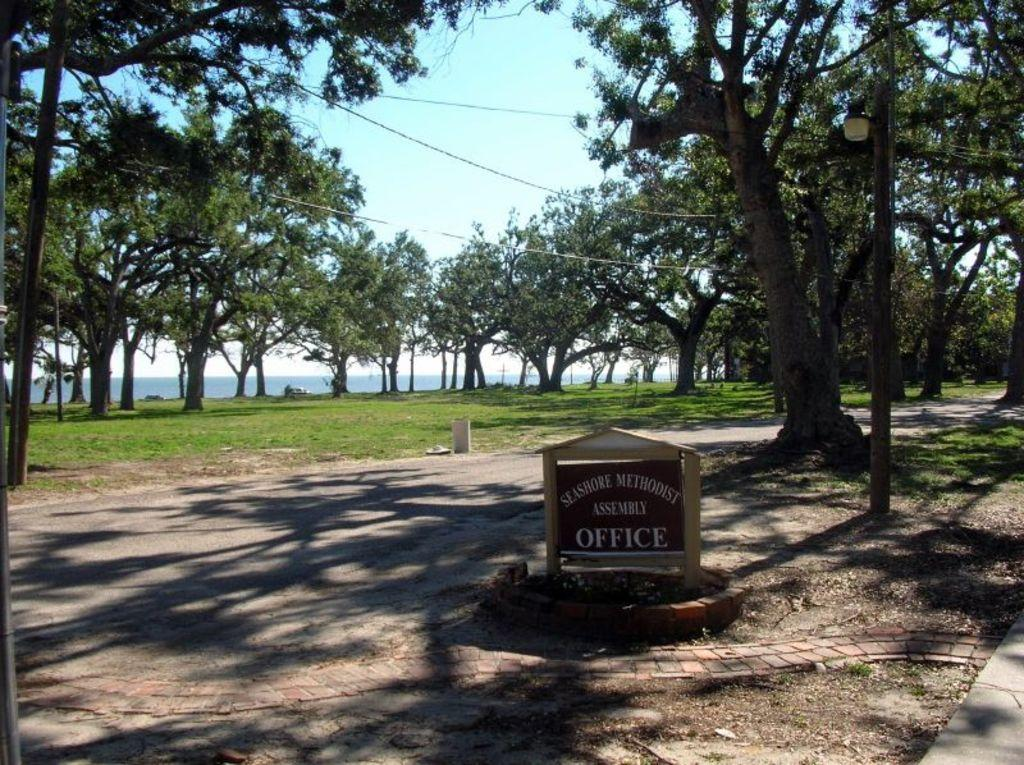What is the main object in the image? There is a sign board in the image. What information does the sign board provide? The sign board has the name of an office. What can be seen behind the sign board? There are trees and grass behind the sign board. What type of surface is visible in the image? There is a water surface visible in the image. What type of juice is being served in the image? There is no juice being served in the image; it features a sign board with the name of an office and a natural setting with trees, grass, and a water surface. Can you see a chain attached to the sign board in the image? There is no chain attached to the sign board in the image. 